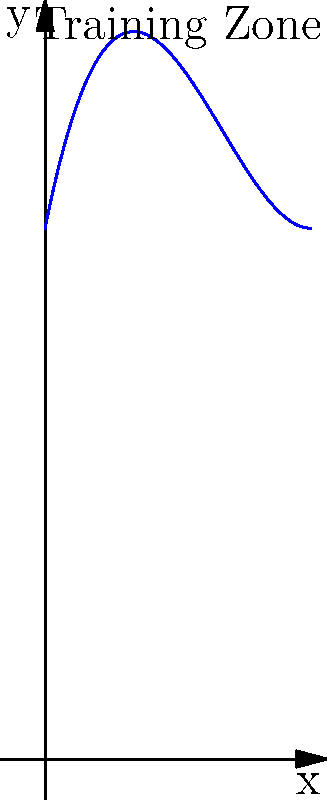As a former player, you're helping design a new training zone on the football field. The irregular shape of the zone can be modeled by the polynomial function $f(x) = 0.2x^3 - 2x^2 + 5x + 10$, where $x$ and $f(x)$ are measured in meters. Calculate the area of this training zone between $x = 0$ and $x = 5$ meters. To find the area under the curve, we need to integrate the function from 0 to 5:

1) The integral is: $$\int_0^5 (0.2x^3 - 2x^2 + 5x + 10) dx$$

2) Integrate each term:
   $$\left[\frac{0.2x^4}{4} - \frac{2x^3}{3} + \frac{5x^2}{2} + 10x\right]_0^5$$

3) Evaluate at the upper and lower bounds:
   $$\left(\frac{0.2(5^4)}{4} - \frac{2(5^3)}{3} + \frac{5(5^2)}{2} + 10(5)\right) - \left(\frac{0.2(0^4)}{4} - \frac{2(0^3)}{3} + \frac{5(0^2)}{2} + 10(0)\right)$$

4) Simplify:
   $$(62.5 - 83.33 + 62.5 + 50) - (0 - 0 + 0 + 0) = 91.67$$

Therefore, the area of the training zone is approximately 91.67 square meters.
Answer: 91.67 square meters 